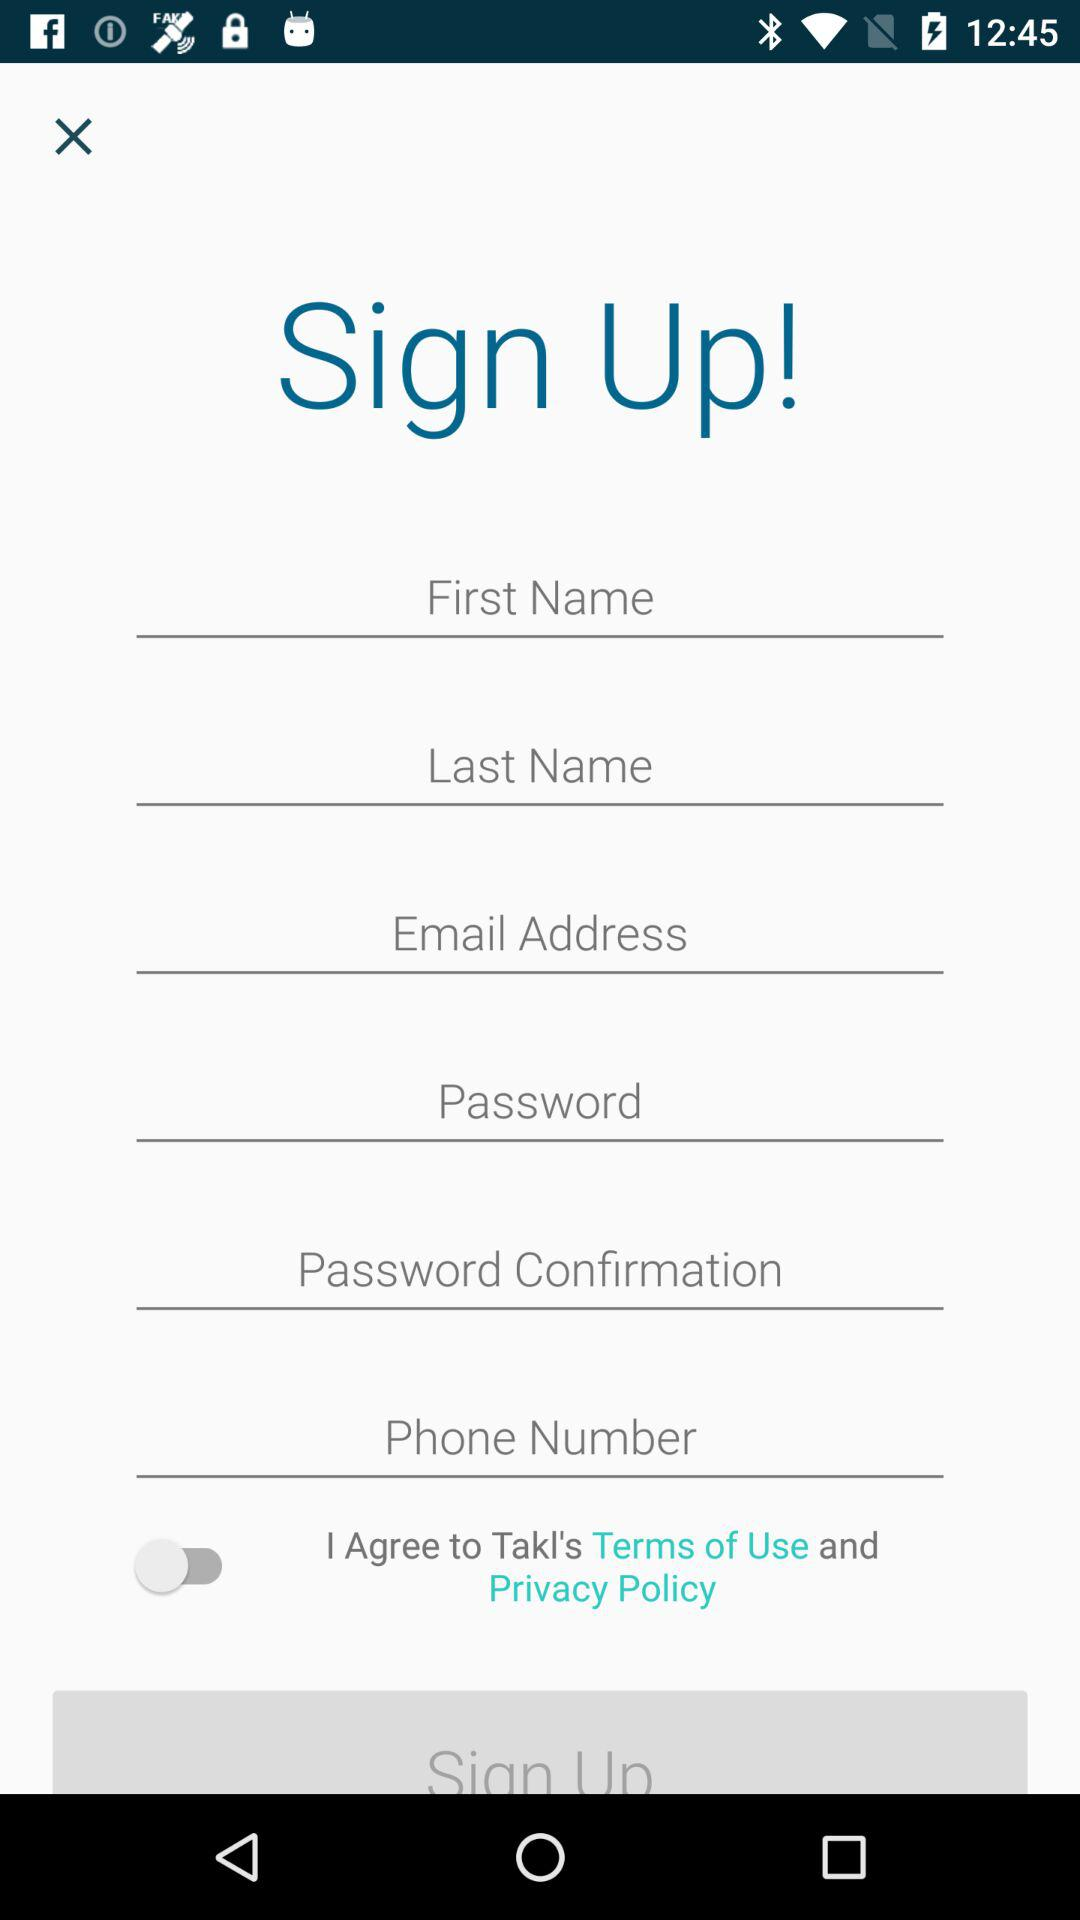How many text inputs are there for the user to fill out?
Answer the question using a single word or phrase. 6 